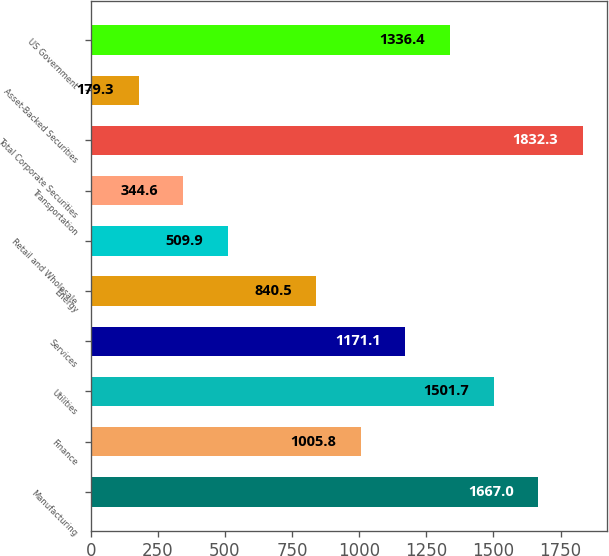Convert chart to OTSL. <chart><loc_0><loc_0><loc_500><loc_500><bar_chart><fcel>Manufacturing<fcel>Finance<fcel>Utilities<fcel>Services<fcel>Energy<fcel>Retail and Wholesale<fcel>Transportation<fcel>Total Corporate Securities<fcel>Asset-Backed Securities<fcel>US Government<nl><fcel>1667<fcel>1005.8<fcel>1501.7<fcel>1171.1<fcel>840.5<fcel>509.9<fcel>344.6<fcel>1832.3<fcel>179.3<fcel>1336.4<nl></chart> 